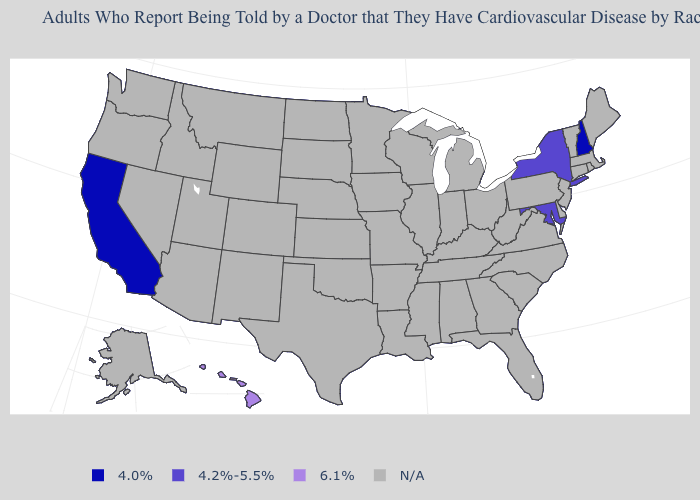What is the value of Oklahoma?
Be succinct. N/A. Name the states that have a value in the range N/A?
Answer briefly. Alabama, Alaska, Arizona, Arkansas, Colorado, Connecticut, Delaware, Florida, Georgia, Idaho, Illinois, Indiana, Iowa, Kansas, Kentucky, Louisiana, Maine, Massachusetts, Michigan, Minnesota, Mississippi, Missouri, Montana, Nebraska, Nevada, New Jersey, New Mexico, North Carolina, North Dakota, Ohio, Oklahoma, Oregon, Pennsylvania, Rhode Island, South Carolina, South Dakota, Tennessee, Texas, Utah, Vermont, Virginia, Washington, West Virginia, Wisconsin, Wyoming. Name the states that have a value in the range 4.0%?
Quick response, please. California, New Hampshire. Name the states that have a value in the range N/A?
Concise answer only. Alabama, Alaska, Arizona, Arkansas, Colorado, Connecticut, Delaware, Florida, Georgia, Idaho, Illinois, Indiana, Iowa, Kansas, Kentucky, Louisiana, Maine, Massachusetts, Michigan, Minnesota, Mississippi, Missouri, Montana, Nebraska, Nevada, New Jersey, New Mexico, North Carolina, North Dakota, Ohio, Oklahoma, Oregon, Pennsylvania, Rhode Island, South Carolina, South Dakota, Tennessee, Texas, Utah, Vermont, Virginia, Washington, West Virginia, Wisconsin, Wyoming. Name the states that have a value in the range 6.1%?
Be succinct. Hawaii. What is the value of Florida?
Answer briefly. N/A. Name the states that have a value in the range 4.2%-5.5%?
Keep it brief. Maryland, New York. How many symbols are there in the legend?
Answer briefly. 4. What is the lowest value in the USA?
Quick response, please. 4.0%. What is the value of Iowa?
Concise answer only. N/A. Name the states that have a value in the range 4.2%-5.5%?
Give a very brief answer. Maryland, New York. Name the states that have a value in the range 4.2%-5.5%?
Quick response, please. Maryland, New York. What is the highest value in the USA?
Be succinct. 6.1%. 